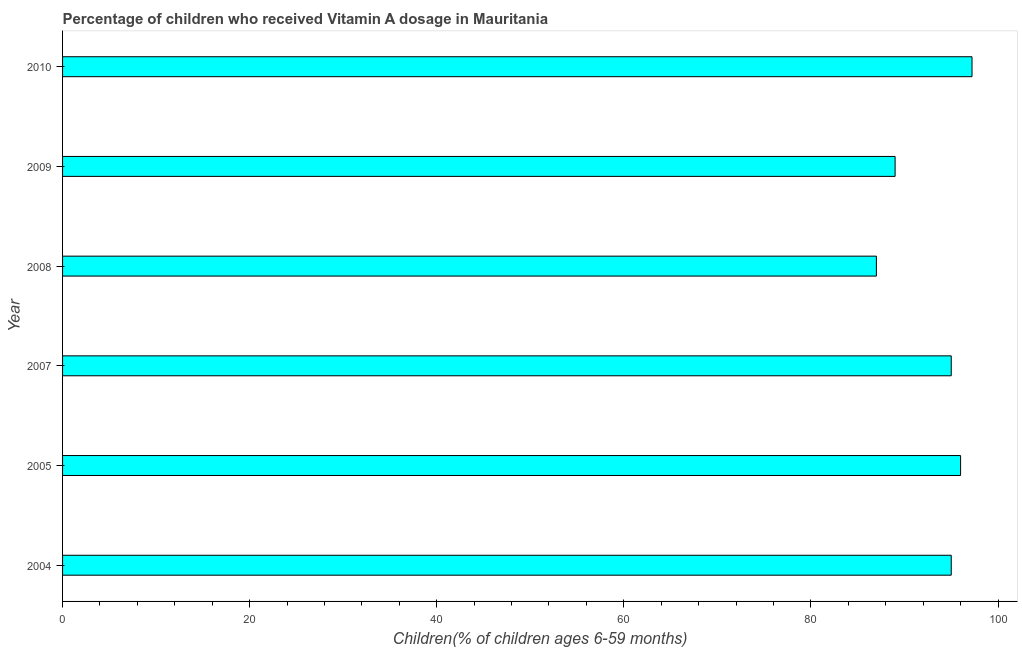Does the graph contain any zero values?
Your response must be concise. No. What is the title of the graph?
Your response must be concise. Percentage of children who received Vitamin A dosage in Mauritania. What is the label or title of the X-axis?
Your response must be concise. Children(% of children ages 6-59 months). What is the vitamin a supplementation coverage rate in 2008?
Make the answer very short. 87. Across all years, what is the maximum vitamin a supplementation coverage rate?
Make the answer very short. 97.22. In which year was the vitamin a supplementation coverage rate maximum?
Ensure brevity in your answer.  2010. In which year was the vitamin a supplementation coverage rate minimum?
Ensure brevity in your answer.  2008. What is the sum of the vitamin a supplementation coverage rate?
Your answer should be compact. 559.22. What is the difference between the vitamin a supplementation coverage rate in 2007 and 2008?
Your response must be concise. 8. What is the average vitamin a supplementation coverage rate per year?
Ensure brevity in your answer.  93.2. What is the median vitamin a supplementation coverage rate?
Provide a succinct answer. 95. In how many years, is the vitamin a supplementation coverage rate greater than 28 %?
Make the answer very short. 6. What is the ratio of the vitamin a supplementation coverage rate in 2005 to that in 2010?
Your answer should be compact. 0.99. Is the vitamin a supplementation coverage rate in 2004 less than that in 2009?
Your answer should be compact. No. Is the difference between the vitamin a supplementation coverage rate in 2005 and 2007 greater than the difference between any two years?
Keep it short and to the point. No. What is the difference between the highest and the second highest vitamin a supplementation coverage rate?
Give a very brief answer. 1.22. What is the difference between the highest and the lowest vitamin a supplementation coverage rate?
Provide a succinct answer. 10.22. In how many years, is the vitamin a supplementation coverage rate greater than the average vitamin a supplementation coverage rate taken over all years?
Provide a short and direct response. 4. Are all the bars in the graph horizontal?
Provide a succinct answer. Yes. How many years are there in the graph?
Your answer should be very brief. 6. What is the Children(% of children ages 6-59 months) of 2004?
Provide a short and direct response. 95. What is the Children(% of children ages 6-59 months) of 2005?
Give a very brief answer. 96. What is the Children(% of children ages 6-59 months) in 2009?
Ensure brevity in your answer.  89. What is the Children(% of children ages 6-59 months) in 2010?
Provide a short and direct response. 97.22. What is the difference between the Children(% of children ages 6-59 months) in 2004 and 2008?
Provide a succinct answer. 8. What is the difference between the Children(% of children ages 6-59 months) in 2004 and 2009?
Your answer should be very brief. 6. What is the difference between the Children(% of children ages 6-59 months) in 2004 and 2010?
Your response must be concise. -2.22. What is the difference between the Children(% of children ages 6-59 months) in 2005 and 2007?
Provide a short and direct response. 1. What is the difference between the Children(% of children ages 6-59 months) in 2005 and 2008?
Offer a very short reply. 9. What is the difference between the Children(% of children ages 6-59 months) in 2005 and 2010?
Your answer should be compact. -1.22. What is the difference between the Children(% of children ages 6-59 months) in 2007 and 2009?
Ensure brevity in your answer.  6. What is the difference between the Children(% of children ages 6-59 months) in 2007 and 2010?
Offer a very short reply. -2.22. What is the difference between the Children(% of children ages 6-59 months) in 2008 and 2010?
Keep it short and to the point. -10.22. What is the difference between the Children(% of children ages 6-59 months) in 2009 and 2010?
Make the answer very short. -8.22. What is the ratio of the Children(% of children ages 6-59 months) in 2004 to that in 2005?
Your response must be concise. 0.99. What is the ratio of the Children(% of children ages 6-59 months) in 2004 to that in 2008?
Your answer should be compact. 1.09. What is the ratio of the Children(% of children ages 6-59 months) in 2004 to that in 2009?
Ensure brevity in your answer.  1.07. What is the ratio of the Children(% of children ages 6-59 months) in 2004 to that in 2010?
Give a very brief answer. 0.98. What is the ratio of the Children(% of children ages 6-59 months) in 2005 to that in 2007?
Your answer should be compact. 1.01. What is the ratio of the Children(% of children ages 6-59 months) in 2005 to that in 2008?
Offer a very short reply. 1.1. What is the ratio of the Children(% of children ages 6-59 months) in 2005 to that in 2009?
Give a very brief answer. 1.08. What is the ratio of the Children(% of children ages 6-59 months) in 2007 to that in 2008?
Offer a terse response. 1.09. What is the ratio of the Children(% of children ages 6-59 months) in 2007 to that in 2009?
Your response must be concise. 1.07. What is the ratio of the Children(% of children ages 6-59 months) in 2007 to that in 2010?
Provide a succinct answer. 0.98. What is the ratio of the Children(% of children ages 6-59 months) in 2008 to that in 2009?
Offer a very short reply. 0.98. What is the ratio of the Children(% of children ages 6-59 months) in 2008 to that in 2010?
Provide a short and direct response. 0.9. What is the ratio of the Children(% of children ages 6-59 months) in 2009 to that in 2010?
Your answer should be compact. 0.92. 